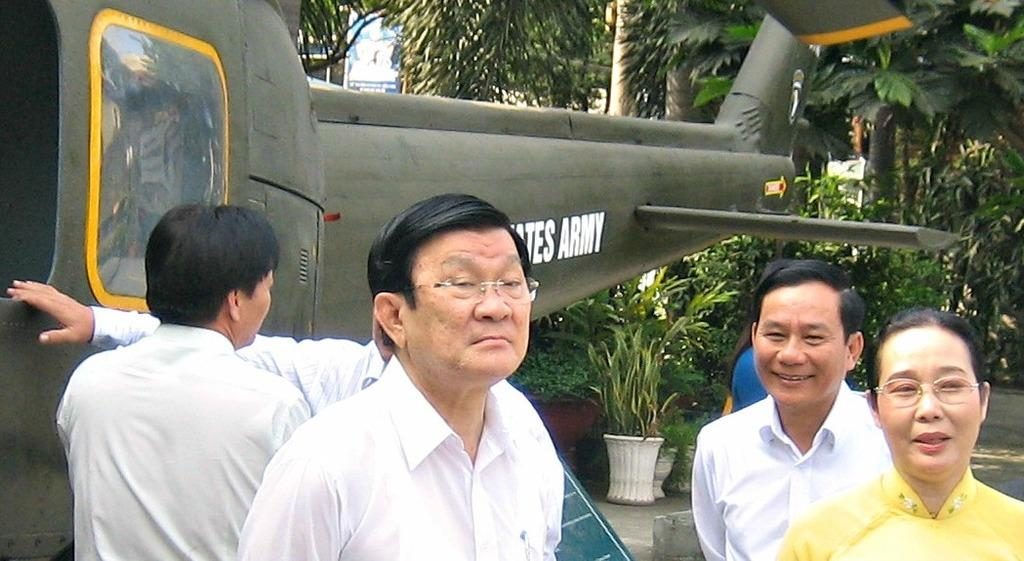<image>
Summarize the visual content of the image. United States Army in white on a green helicopter. 